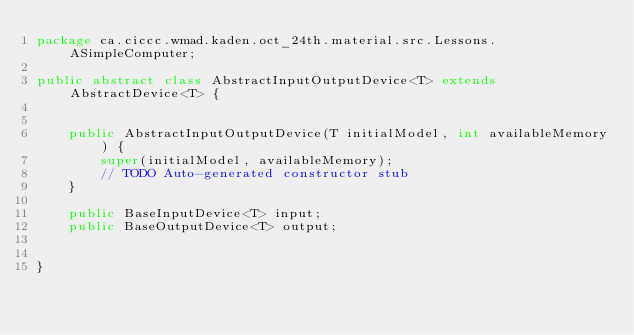<code> <loc_0><loc_0><loc_500><loc_500><_Java_>package ca.ciccc.wmad.kaden.oct_24th.material.src.Lessons.ASimpleComputer;

public abstract class AbstractInputOutputDevice<T> extends AbstractDevice<T> {


    public AbstractInputOutputDevice(T initialModel, int availableMemory) {
        super(initialModel, availableMemory);
        // TODO Auto-generated constructor stub
    }

    public BaseInputDevice<T> input;
    public BaseOutputDevice<T> output;


}
</code> 